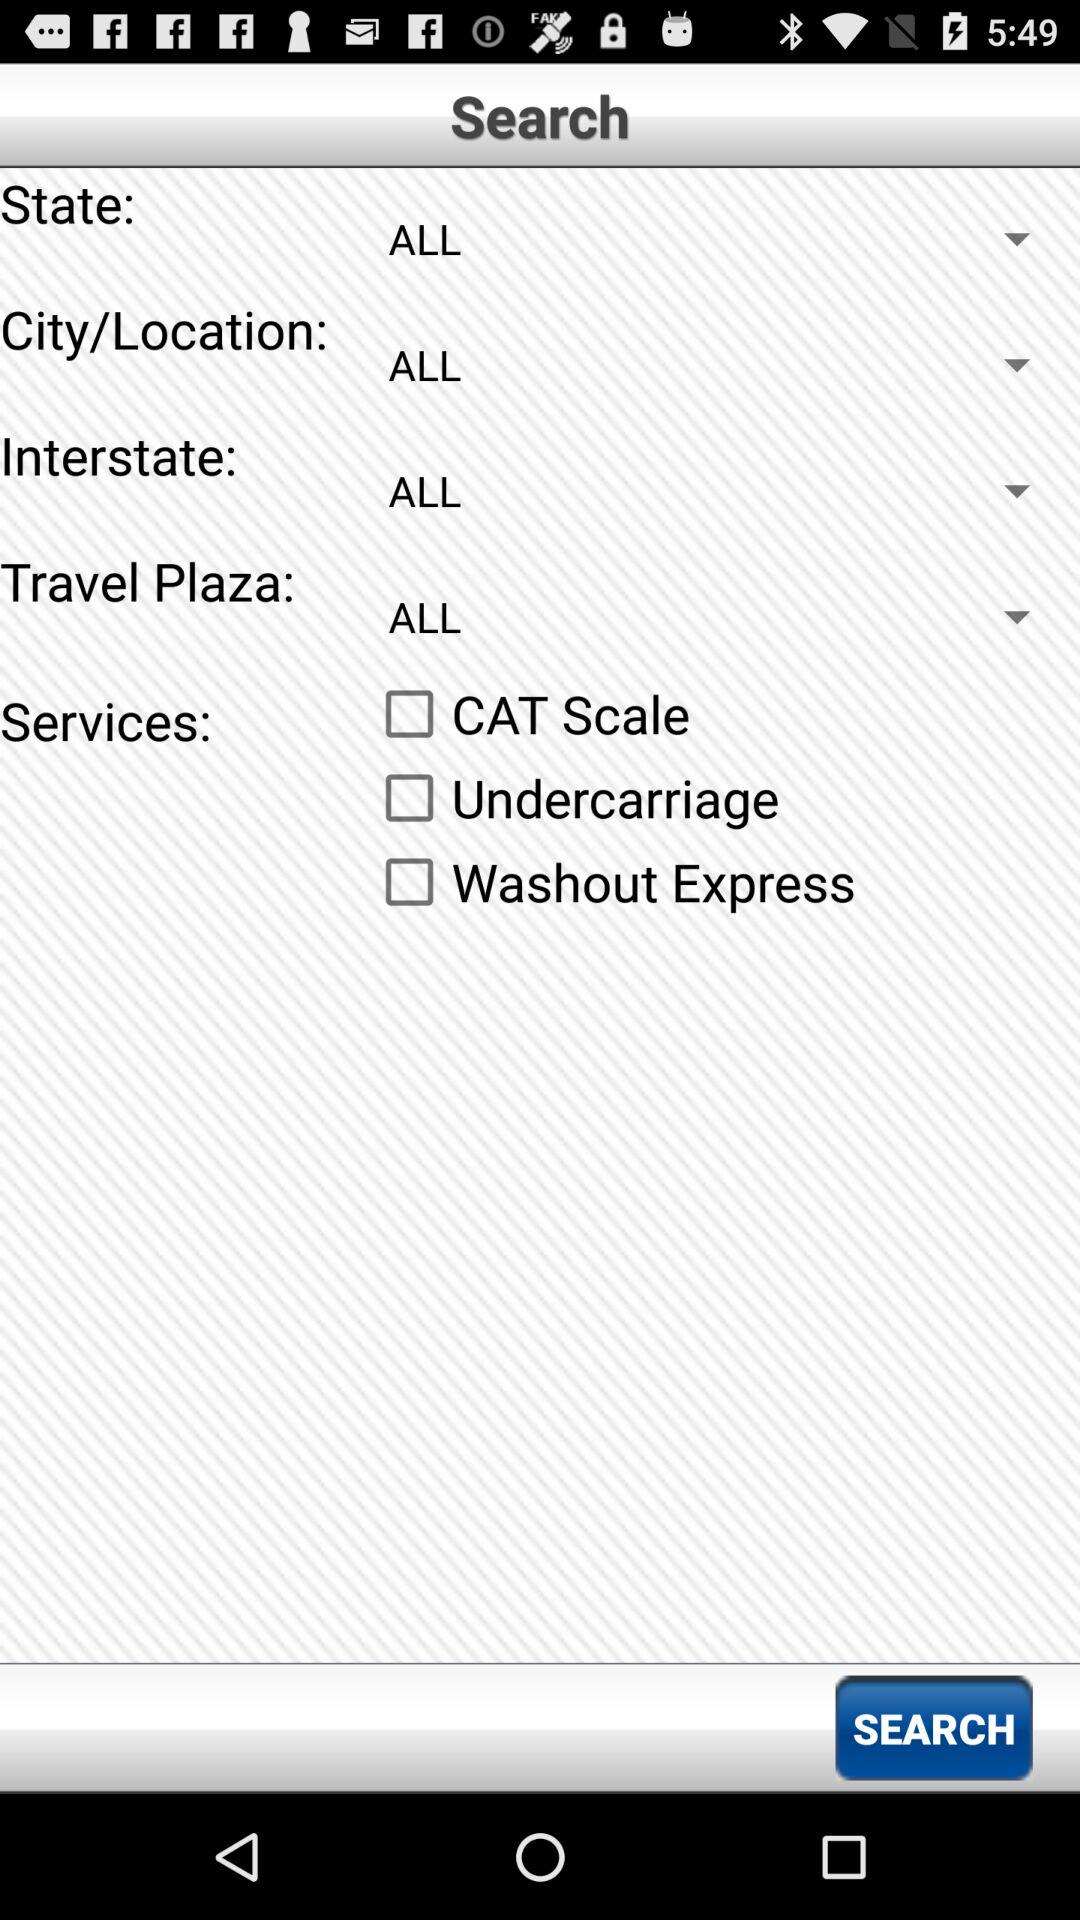How many services are available?
Answer the question using a single word or phrase. 3 